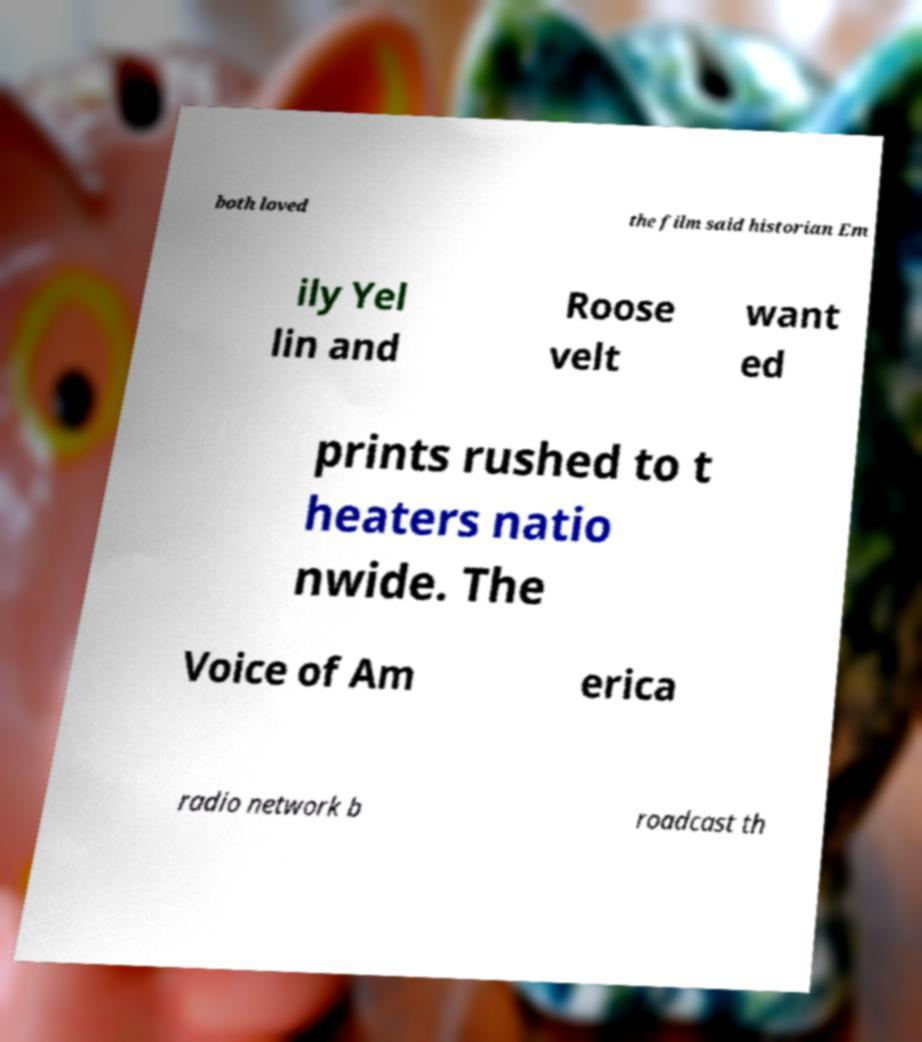What messages or text are displayed in this image? I need them in a readable, typed format. both loved the film said historian Em ily Yel lin and Roose velt want ed prints rushed to t heaters natio nwide. The Voice of Am erica radio network b roadcast th 